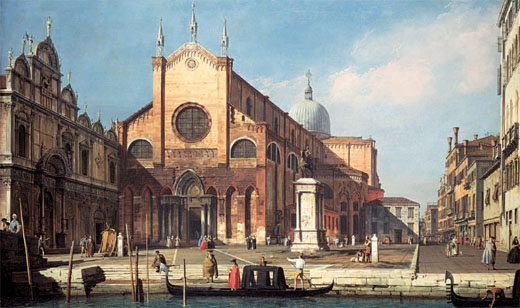Can you describe the main architectural features in this scene? The main architectural features in this Venetian cityscape include a grand, Gothic-style church that dominates the center of the image. The church is characterized by its large, imposing dome, which is a hallmark of Venetian Gothic architecture. Flanking the dome are two tall, elegant towers that add to the verticality of the structure. The facade of the church is richly decorated with arched windows and detailed masonry, showcasing the skill and precision of the craftsmen. Nearby buildings also exhibit the distinctive Gothic style with pointed arches, intricate stonework, and an overall sense of grandeur. The entire scene is a testament to the architectural opulence and historic significance of Venetian buildings. 